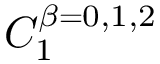<formula> <loc_0><loc_0><loc_500><loc_500>C _ { 1 } ^ { \beta = 0 , 1 , 2 }</formula> 